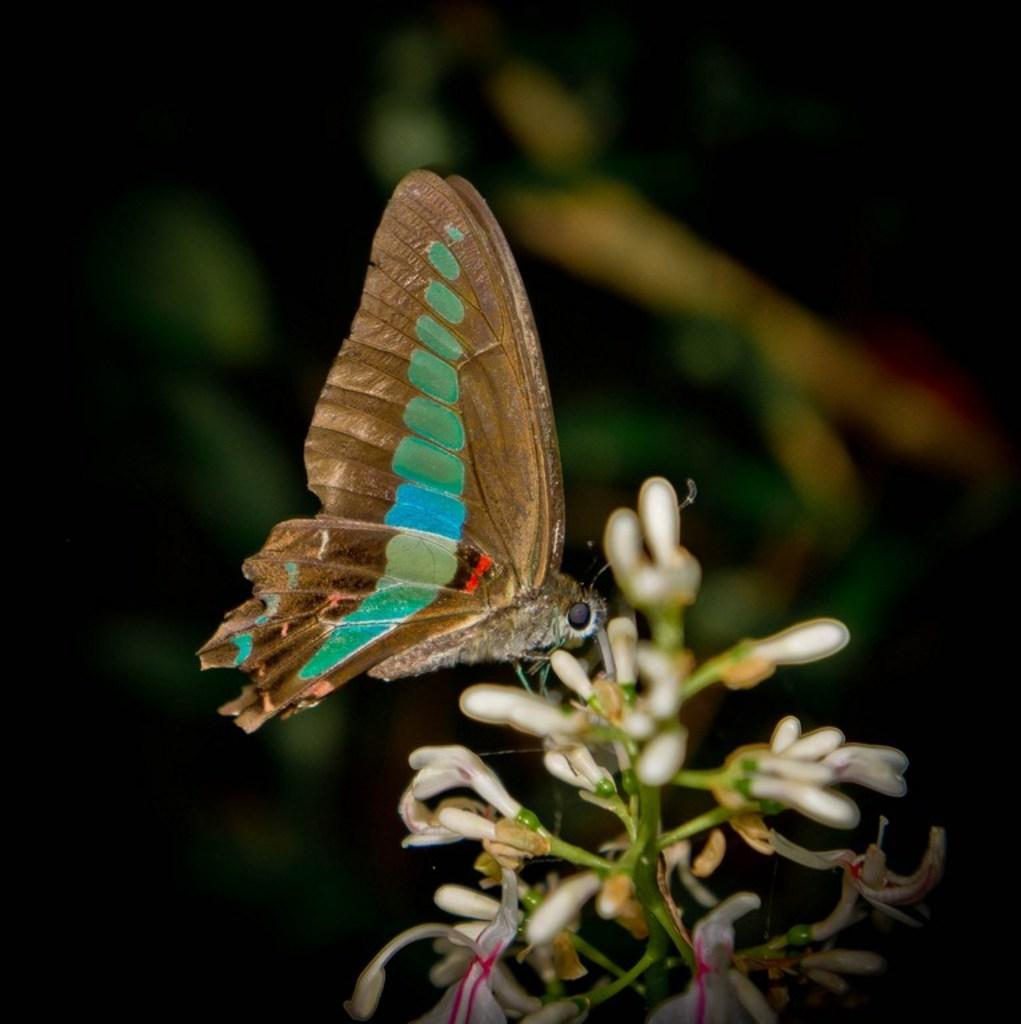What is the main object in the image? There is a stem in the image. What is attached to the stem? There are flowers on the stem. Is there any other living creature in the image? Yes, there is a butterfly on the flowers. How would you describe the background of the image? The background of the image is blurred. Can you tell me how many ants are crawling on the texture of the library in the image? There are no ants or libraries present in the image; it features a stem with flowers and a butterfly. 